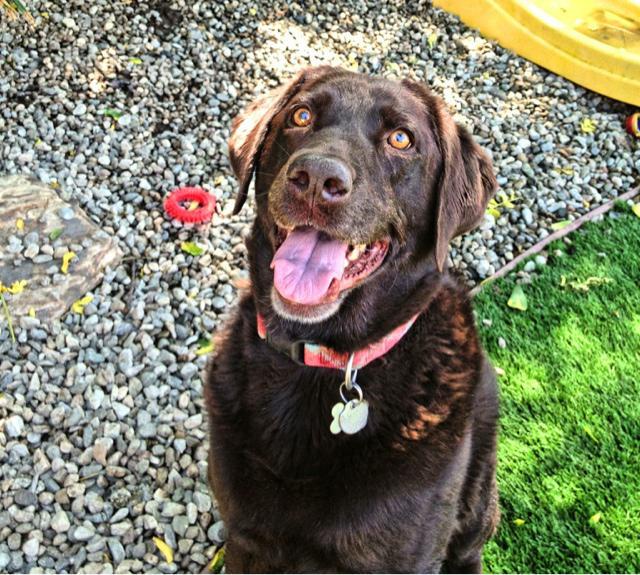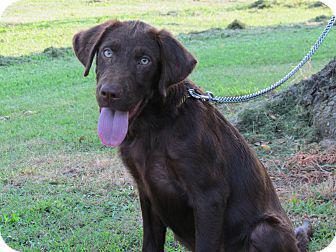The first image is the image on the left, the second image is the image on the right. Evaluate the accuracy of this statement regarding the images: "There is at least one dog whose mouth is completely closed.". Is it true? Answer yes or no. No. The first image is the image on the left, the second image is the image on the right. Evaluate the accuracy of this statement regarding the images: "The dog in one of the images is wearing a red collar around its neck.". Is it true? Answer yes or no. Yes. 